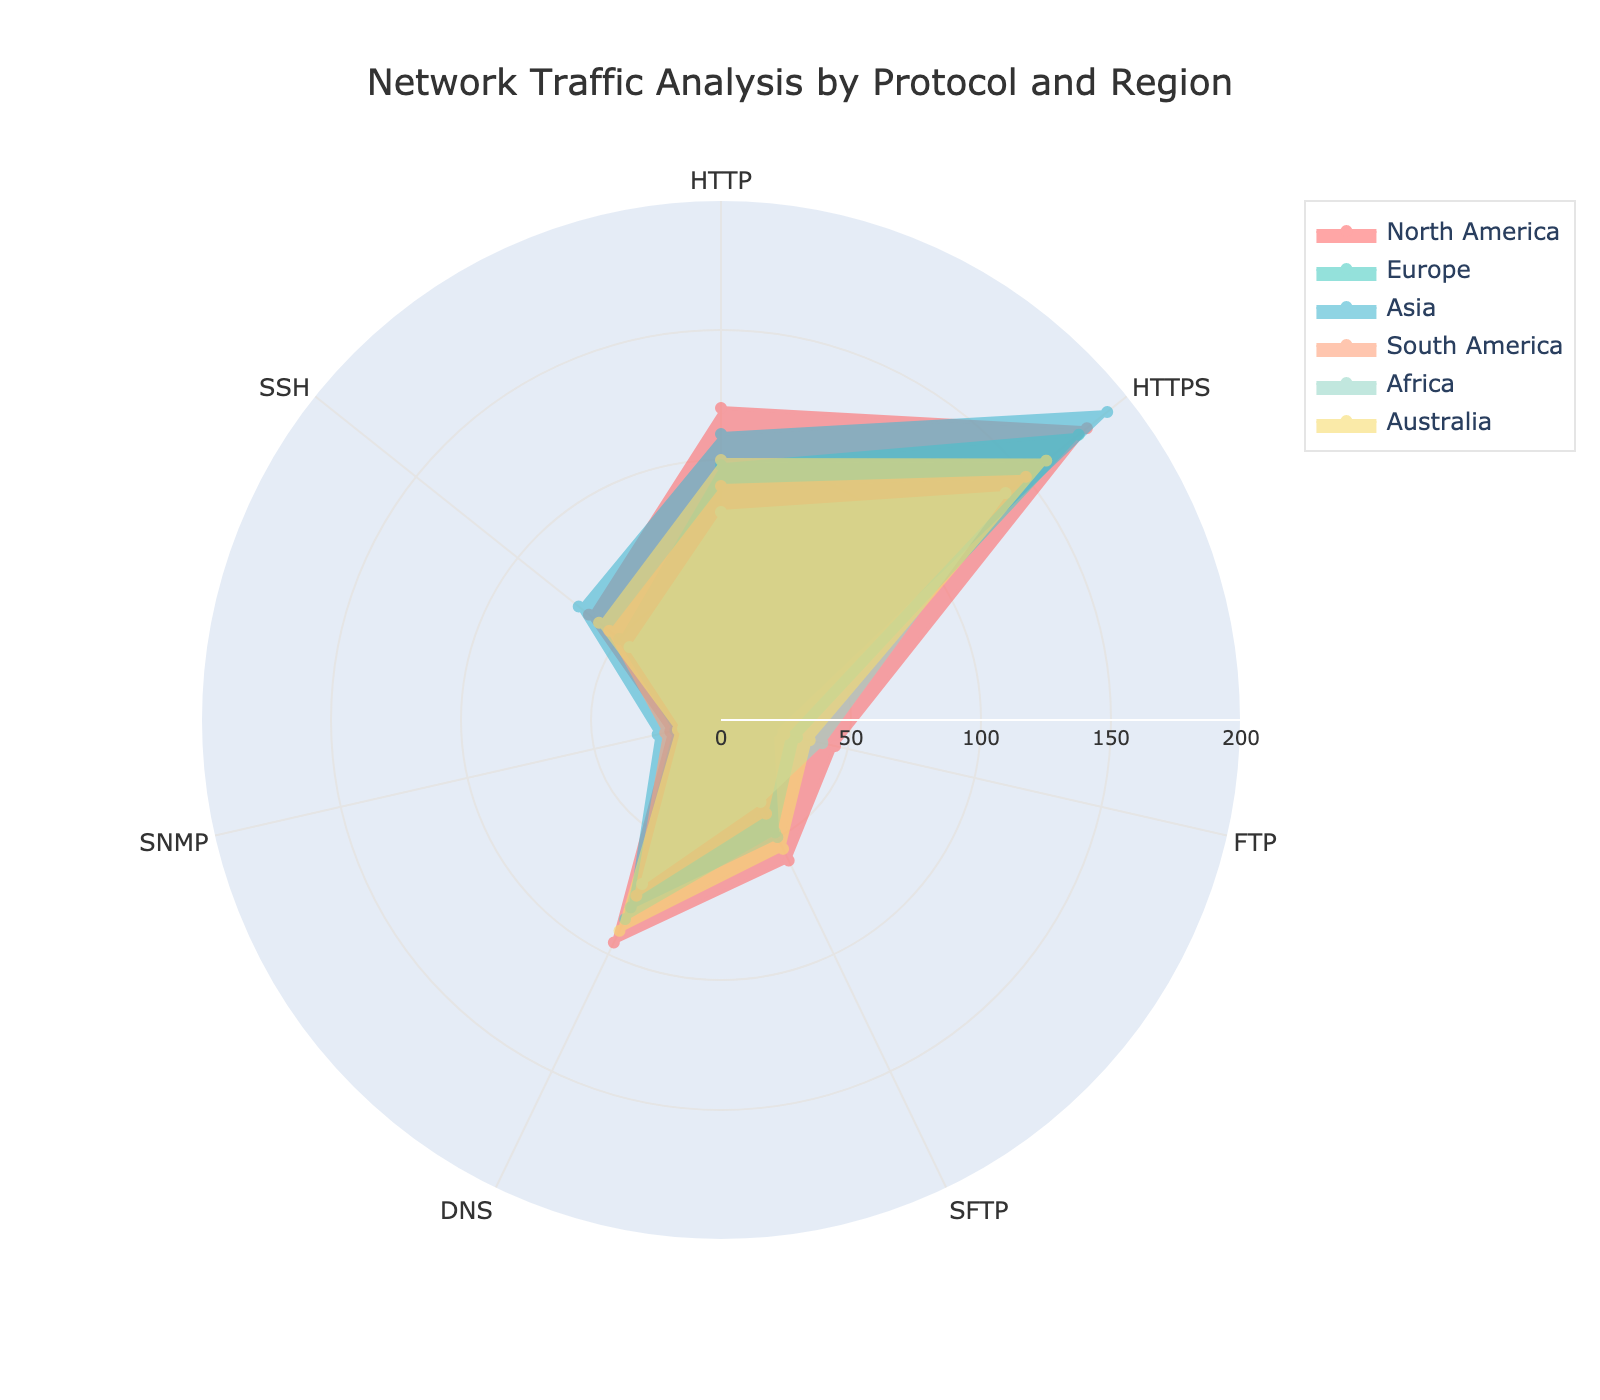Which region has the highest HTTP traffic? By observing the HTTP values on the radar chart, we can see that North America has the highest HTTP traffic with a value of 120.
Answer: North America What is the difference in HTTPS traffic between Europe and Asia? Referring to the radar chart, Europe’s HTTPS traffic is 176 and Asia’s is 190. The difference is 190 - 176.
Answer: 14 Which protocol shows the least variation across different regions? Analyzing the spread of values for each protocol on the radar chart, DNS has relatively close values across all regions compared to other protocols.
Answer: DNS Which region has the least SNMP traffic? By examining the SNMP traffic values, Africa has the least SNMP traffic with a value of 15.
Answer: Africa How does SSH traffic in Australia compare to that in South America? Reviewing the SSH values, Australia has 60 and South America has 55. Australia has higher SSH traffic by 5 units.
Answer: Australia, 5 more What is the total FTP traffic across all regions? Summing the FTP traffic values from the chart: 45 (North America) + 30 (Europe) + 20 (Asia) + 25 (South America) + 40 (Africa) + 35 (Australia) = 195.
Answer: 195 Which protocol has the highest traffic in Europe? Looking at Europe's values, HTTPS has the highest traffic at 176.
Answer: HTTPS How much more SFTP traffic does North America have compared to Africa? North America has 60 for SFTP and Africa has 35. The difference is 60 - 35.
Answer: 25 Are there any regions where DNS traffic is the highest among all protocols? Reviewing the DNS values compared to other protocols in each region, no region has DNS as the highest traffic protocol.
Answer: No Which protocol in Asia has the lowest traffic? Observing the values for Asia, FTP has the lowest traffic at 20.
Answer: FTP 